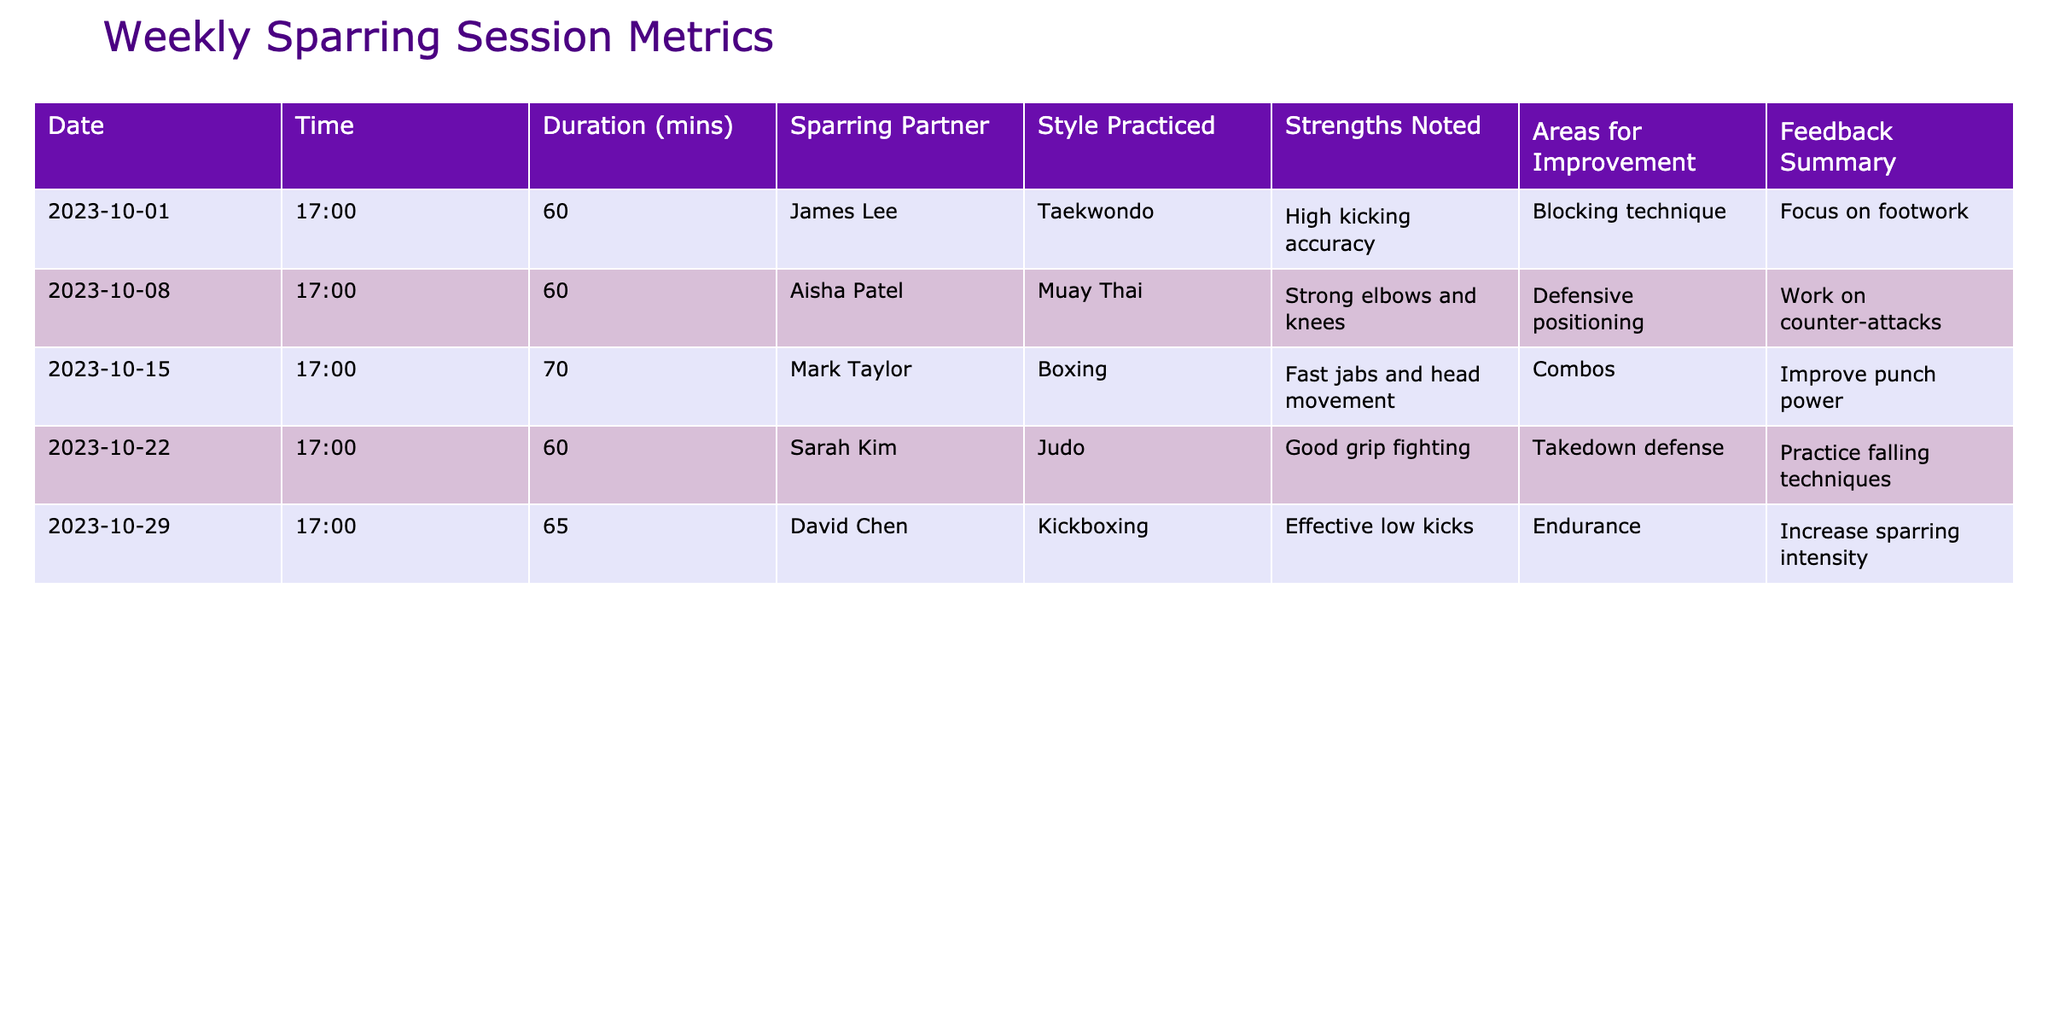What was the longest sparring session duration recorded? The longest duration can be found by comparing the "Duration (mins)" values. The times recorded are 60, 60, 70, 60, and 65 minutes. The highest value is 70 minutes from the session with Mark Taylor.
Answer: 70 minutes Who practiced Muay Thai during the week of October 8? The table shows that on October 8, Aisha Patel was the sparring partner, and the style practiced was Muay Thai.
Answer: Aisha Patel How many sparring sessions focused on striking styles (Taekwondo, Boxing, and Kickboxing)? To determine this, we check the "Style Practiced" column. The striking styles are Taekwondo, Boxing, and Kickboxing. There are three such sessions on October 1, October 15, and October 29, making it three sessions.
Answer: 3 Did any session have a noted strength in defensive positioning? Looking through the "Strengths Noted" column, defensive positioning is specifically mentioned during the session with Aisha Patel on October 8, confirming that there was such a case.
Answer: Yes What is the average duration of the sparring sessions? The durations recorded are 60, 60, 70, 60, and 65 minutes. To calculate the average, first sum these values: 60 + 60 + 70 + 60 + 65 = 315 minutes. Then, divide by the number of sessions (5): 315/5 = 63 minutes.
Answer: 63 minutes What was the strength noted for the sparring session on October 22? The "Strengths Noted" column indicates that during the session on October 22 with Sarah Kim, the noted strength was good grip fighting.
Answer: Good grip fighting Which sparring session emphasized the need to work on counter-attacks? By reviewing the "Areas for Improvement" column, we see that the session with Aisha Patel on October 8 noted counter-attacks as an area for improvement.
Answer: Aisha Patel on October 8 Was there a specific area for improvement noted for every sparring session? Checking each row in the "Areas for Improvement" column, every session indeed has a specified area for improvement, confirming that this is true for all the recorded sessions.
Answer: Yes 